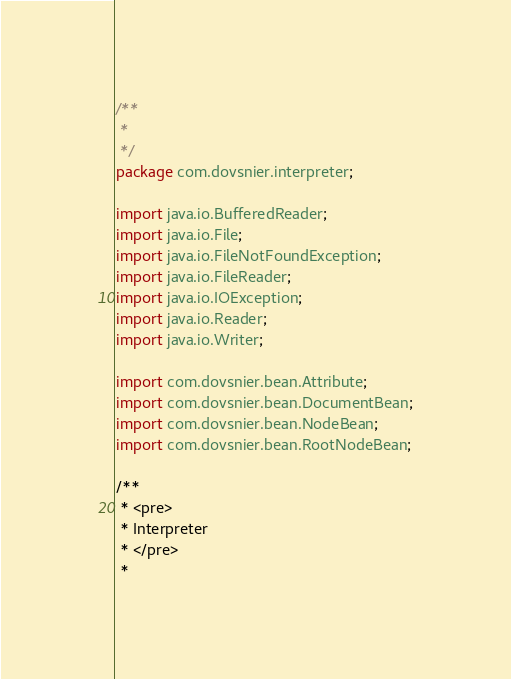Convert code to text. <code><loc_0><loc_0><loc_500><loc_500><_Java_>/**
 * 
 */
package com.dovsnier.interpreter;

import java.io.BufferedReader;
import java.io.File;
import java.io.FileNotFoundException;
import java.io.FileReader;
import java.io.IOException;
import java.io.Reader;
import java.io.Writer;

import com.dovsnier.bean.Attribute;
import com.dovsnier.bean.DocumentBean;
import com.dovsnier.bean.NodeBean;
import com.dovsnier.bean.RootNodeBean;

/**
 * <pre>
 * Interpreter
 * </pre>
 * </code> 